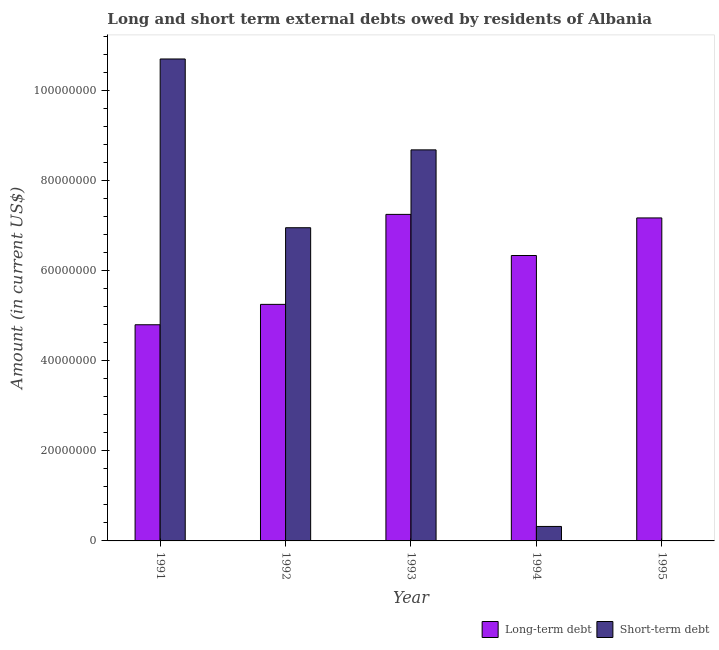How many bars are there on the 2nd tick from the left?
Provide a succinct answer. 2. How many bars are there on the 2nd tick from the right?
Your answer should be compact. 2. What is the long-term debts owed by residents in 1995?
Ensure brevity in your answer.  7.18e+07. Across all years, what is the maximum long-term debts owed by residents?
Ensure brevity in your answer.  7.26e+07. In which year was the short-term debts owed by residents maximum?
Your answer should be compact. 1991. What is the total long-term debts owed by residents in the graph?
Your answer should be compact. 3.08e+08. What is the difference between the long-term debts owed by residents in 1993 and that in 1994?
Give a very brief answer. 9.14e+06. What is the difference between the short-term debts owed by residents in 1991 and the long-term debts owed by residents in 1992?
Provide a short and direct response. 3.75e+07. What is the average long-term debts owed by residents per year?
Offer a very short reply. 6.17e+07. In how many years, is the long-term debts owed by residents greater than 60000000 US$?
Your answer should be compact. 3. What is the ratio of the short-term debts owed by residents in 1993 to that in 1994?
Provide a succinct answer. 27. Is the long-term debts owed by residents in 1991 less than that in 1995?
Offer a terse response. Yes. Is the difference between the long-term debts owed by residents in 1994 and 1995 greater than the difference between the short-term debts owed by residents in 1994 and 1995?
Your response must be concise. No. What is the difference between the highest and the second highest long-term debts owed by residents?
Your answer should be compact. 7.87e+05. What is the difference between the highest and the lowest long-term debts owed by residents?
Give a very brief answer. 2.45e+07. How many bars are there?
Your answer should be very brief. 9. Are all the bars in the graph horizontal?
Ensure brevity in your answer.  No. How many years are there in the graph?
Provide a short and direct response. 5. What is the difference between two consecutive major ticks on the Y-axis?
Keep it short and to the point. 2.00e+07. Does the graph contain grids?
Offer a very short reply. No. Where does the legend appear in the graph?
Provide a short and direct response. Bottom right. How many legend labels are there?
Provide a short and direct response. 2. What is the title of the graph?
Offer a terse response. Long and short term external debts owed by residents of Albania. Does "Total Population" appear as one of the legend labels in the graph?
Offer a very short reply. No. What is the label or title of the Y-axis?
Offer a very short reply. Amount (in current US$). What is the Amount (in current US$) of Long-term debt in 1991?
Provide a short and direct response. 4.80e+07. What is the Amount (in current US$) of Short-term debt in 1991?
Offer a terse response. 1.07e+08. What is the Amount (in current US$) of Long-term debt in 1992?
Ensure brevity in your answer.  5.26e+07. What is the Amount (in current US$) in Short-term debt in 1992?
Ensure brevity in your answer.  6.96e+07. What is the Amount (in current US$) of Long-term debt in 1993?
Your answer should be very brief. 7.26e+07. What is the Amount (in current US$) in Short-term debt in 1993?
Provide a short and direct response. 8.69e+07. What is the Amount (in current US$) of Long-term debt in 1994?
Provide a short and direct response. 6.34e+07. What is the Amount (in current US$) of Short-term debt in 1994?
Give a very brief answer. 3.22e+06. What is the Amount (in current US$) of Long-term debt in 1995?
Make the answer very short. 7.18e+07. What is the Amount (in current US$) in Short-term debt in 1995?
Offer a very short reply. 0. Across all years, what is the maximum Amount (in current US$) in Long-term debt?
Your answer should be compact. 7.26e+07. Across all years, what is the maximum Amount (in current US$) of Short-term debt?
Provide a short and direct response. 1.07e+08. Across all years, what is the minimum Amount (in current US$) of Long-term debt?
Your answer should be very brief. 4.80e+07. What is the total Amount (in current US$) in Long-term debt in the graph?
Keep it short and to the point. 3.08e+08. What is the total Amount (in current US$) of Short-term debt in the graph?
Your answer should be compact. 2.67e+08. What is the difference between the Amount (in current US$) of Long-term debt in 1991 and that in 1992?
Make the answer very short. -4.53e+06. What is the difference between the Amount (in current US$) in Short-term debt in 1991 and that in 1992?
Give a very brief answer. 3.75e+07. What is the difference between the Amount (in current US$) in Long-term debt in 1991 and that in 1993?
Provide a short and direct response. -2.45e+07. What is the difference between the Amount (in current US$) in Short-term debt in 1991 and that in 1993?
Provide a succinct answer. 2.02e+07. What is the difference between the Amount (in current US$) in Long-term debt in 1991 and that in 1994?
Ensure brevity in your answer.  -1.54e+07. What is the difference between the Amount (in current US$) of Short-term debt in 1991 and that in 1994?
Your response must be concise. 1.04e+08. What is the difference between the Amount (in current US$) of Long-term debt in 1991 and that in 1995?
Give a very brief answer. -2.37e+07. What is the difference between the Amount (in current US$) in Long-term debt in 1992 and that in 1993?
Give a very brief answer. -2.00e+07. What is the difference between the Amount (in current US$) in Short-term debt in 1992 and that in 1993?
Your answer should be compact. -1.73e+07. What is the difference between the Amount (in current US$) of Long-term debt in 1992 and that in 1994?
Ensure brevity in your answer.  -1.09e+07. What is the difference between the Amount (in current US$) in Short-term debt in 1992 and that in 1994?
Give a very brief answer. 6.64e+07. What is the difference between the Amount (in current US$) of Long-term debt in 1992 and that in 1995?
Give a very brief answer. -1.92e+07. What is the difference between the Amount (in current US$) of Long-term debt in 1993 and that in 1994?
Offer a terse response. 9.14e+06. What is the difference between the Amount (in current US$) in Short-term debt in 1993 and that in 1994?
Provide a short and direct response. 8.37e+07. What is the difference between the Amount (in current US$) in Long-term debt in 1993 and that in 1995?
Ensure brevity in your answer.  7.87e+05. What is the difference between the Amount (in current US$) of Long-term debt in 1994 and that in 1995?
Your answer should be very brief. -8.35e+06. What is the difference between the Amount (in current US$) of Long-term debt in 1991 and the Amount (in current US$) of Short-term debt in 1992?
Your answer should be compact. -2.16e+07. What is the difference between the Amount (in current US$) of Long-term debt in 1991 and the Amount (in current US$) of Short-term debt in 1993?
Give a very brief answer. -3.89e+07. What is the difference between the Amount (in current US$) of Long-term debt in 1991 and the Amount (in current US$) of Short-term debt in 1994?
Your response must be concise. 4.48e+07. What is the difference between the Amount (in current US$) in Long-term debt in 1992 and the Amount (in current US$) in Short-term debt in 1993?
Offer a very short reply. -3.43e+07. What is the difference between the Amount (in current US$) of Long-term debt in 1992 and the Amount (in current US$) of Short-term debt in 1994?
Your response must be concise. 4.93e+07. What is the difference between the Amount (in current US$) of Long-term debt in 1993 and the Amount (in current US$) of Short-term debt in 1994?
Your answer should be very brief. 6.93e+07. What is the average Amount (in current US$) of Long-term debt per year?
Make the answer very short. 6.17e+07. What is the average Amount (in current US$) in Short-term debt per year?
Your answer should be compact. 5.34e+07. In the year 1991, what is the difference between the Amount (in current US$) in Long-term debt and Amount (in current US$) in Short-term debt?
Make the answer very short. -5.91e+07. In the year 1992, what is the difference between the Amount (in current US$) of Long-term debt and Amount (in current US$) of Short-term debt?
Your answer should be compact. -1.70e+07. In the year 1993, what is the difference between the Amount (in current US$) of Long-term debt and Amount (in current US$) of Short-term debt?
Make the answer very short. -1.43e+07. In the year 1994, what is the difference between the Amount (in current US$) in Long-term debt and Amount (in current US$) in Short-term debt?
Offer a very short reply. 6.02e+07. What is the ratio of the Amount (in current US$) of Long-term debt in 1991 to that in 1992?
Provide a succinct answer. 0.91. What is the ratio of the Amount (in current US$) of Short-term debt in 1991 to that in 1992?
Offer a very short reply. 1.54. What is the ratio of the Amount (in current US$) of Long-term debt in 1991 to that in 1993?
Your answer should be compact. 0.66. What is the ratio of the Amount (in current US$) in Short-term debt in 1991 to that in 1993?
Your answer should be compact. 1.23. What is the ratio of the Amount (in current US$) in Long-term debt in 1991 to that in 1994?
Provide a succinct answer. 0.76. What is the ratio of the Amount (in current US$) of Short-term debt in 1991 to that in 1994?
Make the answer very short. 33.28. What is the ratio of the Amount (in current US$) of Long-term debt in 1991 to that in 1995?
Your answer should be compact. 0.67. What is the ratio of the Amount (in current US$) in Long-term debt in 1992 to that in 1993?
Your answer should be very brief. 0.72. What is the ratio of the Amount (in current US$) in Short-term debt in 1992 to that in 1993?
Keep it short and to the point. 0.8. What is the ratio of the Amount (in current US$) of Long-term debt in 1992 to that in 1994?
Your response must be concise. 0.83. What is the ratio of the Amount (in current US$) of Short-term debt in 1992 to that in 1994?
Give a very brief answer. 21.63. What is the ratio of the Amount (in current US$) in Long-term debt in 1992 to that in 1995?
Keep it short and to the point. 0.73. What is the ratio of the Amount (in current US$) of Long-term debt in 1993 to that in 1994?
Your answer should be compact. 1.14. What is the ratio of the Amount (in current US$) in Short-term debt in 1993 to that in 1994?
Provide a short and direct response. 27. What is the ratio of the Amount (in current US$) of Long-term debt in 1993 to that in 1995?
Offer a very short reply. 1.01. What is the ratio of the Amount (in current US$) in Long-term debt in 1994 to that in 1995?
Ensure brevity in your answer.  0.88. What is the difference between the highest and the second highest Amount (in current US$) in Long-term debt?
Make the answer very short. 7.87e+05. What is the difference between the highest and the second highest Amount (in current US$) in Short-term debt?
Offer a terse response. 2.02e+07. What is the difference between the highest and the lowest Amount (in current US$) in Long-term debt?
Ensure brevity in your answer.  2.45e+07. What is the difference between the highest and the lowest Amount (in current US$) in Short-term debt?
Offer a very short reply. 1.07e+08. 